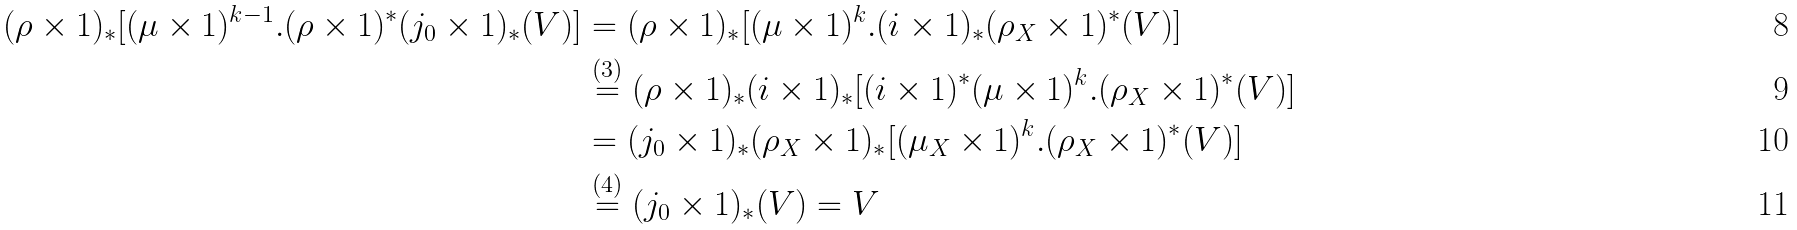<formula> <loc_0><loc_0><loc_500><loc_500>( \rho \times 1 ) _ { * } [ ( \mu \times 1 ) ^ { k - 1 } . ( \rho \times 1 ) ^ { * } ( j _ { 0 } \times 1 ) _ { * } ( V ) ] & = ( \rho \times 1 ) _ { * } [ ( \mu \times 1 ) ^ { k } . ( i \times 1 ) _ { * } ( \rho _ { X } \times 1 ) ^ { * } ( V ) ] \\ & \stackrel { ( 3 ) } { = } ( \rho \times 1 ) _ { * } ( i \times 1 ) _ { * } [ ( i \times 1 ) ^ { * } ( \mu \times 1 ) ^ { k } . ( \rho _ { X } \times 1 ) ^ { * } ( V ) ] \\ & = ( j _ { 0 } \times 1 ) _ { * } ( \rho _ { X } \times 1 ) _ { * } [ ( \mu _ { X } \times 1 ) ^ { k } . ( \rho _ { X } \times 1 ) ^ { * } ( V ) ] \\ & \stackrel { ( 4 ) } { = } ( j _ { 0 } \times 1 ) _ { * } ( V ) = V</formula> 